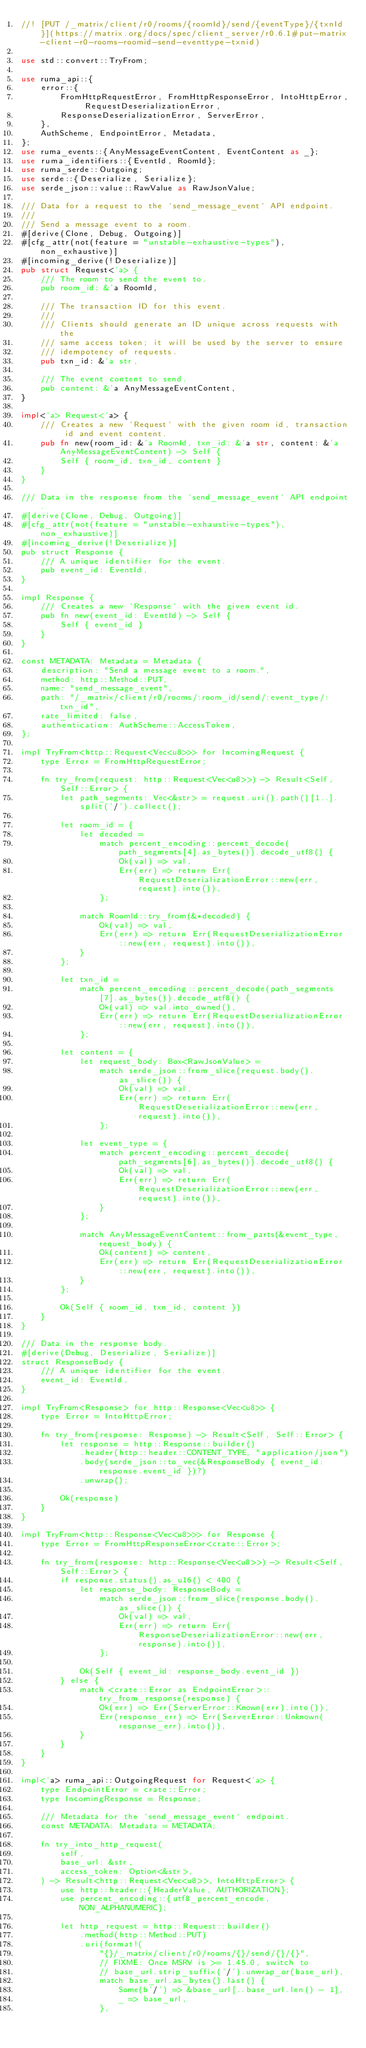<code> <loc_0><loc_0><loc_500><loc_500><_Rust_>//! [PUT /_matrix/client/r0/rooms/{roomId}/send/{eventType}/{txnId}](https://matrix.org/docs/spec/client_server/r0.6.1#put-matrix-client-r0-rooms-roomid-send-eventtype-txnid)

use std::convert::TryFrom;

use ruma_api::{
    error::{
        FromHttpRequestError, FromHttpResponseError, IntoHttpError, RequestDeserializationError,
        ResponseDeserializationError, ServerError,
    },
    AuthScheme, EndpointError, Metadata,
};
use ruma_events::{AnyMessageEventContent, EventContent as _};
use ruma_identifiers::{EventId, RoomId};
use ruma_serde::Outgoing;
use serde::{Deserialize, Serialize};
use serde_json::value::RawValue as RawJsonValue;

/// Data for a request to the `send_message_event` API endpoint.
///
/// Send a message event to a room.
#[derive(Clone, Debug, Outgoing)]
#[cfg_attr(not(feature = "unstable-exhaustive-types"), non_exhaustive)]
#[incoming_derive(!Deserialize)]
pub struct Request<'a> {
    /// The room to send the event to.
    pub room_id: &'a RoomId,

    /// The transaction ID for this event.
    ///
    /// Clients should generate an ID unique across requests with the
    /// same access token; it will be used by the server to ensure
    /// idempotency of requests.
    pub txn_id: &'a str,

    /// The event content to send.
    pub content: &'a AnyMessageEventContent,
}

impl<'a> Request<'a> {
    /// Creates a new `Request` with the given room id, transaction id and event content.
    pub fn new(room_id: &'a RoomId, txn_id: &'a str, content: &'a AnyMessageEventContent) -> Self {
        Self { room_id, txn_id, content }
    }
}

/// Data in the response from the `send_message_event` API endpoint.
#[derive(Clone, Debug, Outgoing)]
#[cfg_attr(not(feature = "unstable-exhaustive-types"), non_exhaustive)]
#[incoming_derive(!Deserialize)]
pub struct Response {
    /// A unique identifier for the event.
    pub event_id: EventId,
}

impl Response {
    /// Creates a new `Response` with the given event id.
    pub fn new(event_id: EventId) -> Self {
        Self { event_id }
    }
}

const METADATA: Metadata = Metadata {
    description: "Send a message event to a room.",
    method: http::Method::PUT,
    name: "send_message_event",
    path: "/_matrix/client/r0/rooms/:room_id/send/:event_type/:txn_id",
    rate_limited: false,
    authentication: AuthScheme::AccessToken,
};

impl TryFrom<http::Request<Vec<u8>>> for IncomingRequest {
    type Error = FromHttpRequestError;

    fn try_from(request: http::Request<Vec<u8>>) -> Result<Self, Self::Error> {
        let path_segments: Vec<&str> = request.uri().path()[1..].split('/').collect();

        let room_id = {
            let decoded =
                match percent_encoding::percent_decode(path_segments[4].as_bytes()).decode_utf8() {
                    Ok(val) => val,
                    Err(err) => return Err(RequestDeserializationError::new(err, request).into()),
                };

            match RoomId::try_from(&*decoded) {
                Ok(val) => val,
                Err(err) => return Err(RequestDeserializationError::new(err, request).into()),
            }
        };

        let txn_id =
            match percent_encoding::percent_decode(path_segments[7].as_bytes()).decode_utf8() {
                Ok(val) => val.into_owned(),
                Err(err) => return Err(RequestDeserializationError::new(err, request).into()),
            };

        let content = {
            let request_body: Box<RawJsonValue> =
                match serde_json::from_slice(request.body().as_slice()) {
                    Ok(val) => val,
                    Err(err) => return Err(RequestDeserializationError::new(err, request).into()),
                };

            let event_type = {
                match percent_encoding::percent_decode(path_segments[6].as_bytes()).decode_utf8() {
                    Ok(val) => val,
                    Err(err) => return Err(RequestDeserializationError::new(err, request).into()),
                }
            };

            match AnyMessageEventContent::from_parts(&event_type, request_body) {
                Ok(content) => content,
                Err(err) => return Err(RequestDeserializationError::new(err, request).into()),
            }
        };

        Ok(Self { room_id, txn_id, content })
    }
}

/// Data in the response body.
#[derive(Debug, Deserialize, Serialize)]
struct ResponseBody {
    /// A unique identifier for the event.
    event_id: EventId,
}

impl TryFrom<Response> for http::Response<Vec<u8>> {
    type Error = IntoHttpError;

    fn try_from(response: Response) -> Result<Self, Self::Error> {
        let response = http::Response::builder()
            .header(http::header::CONTENT_TYPE, "application/json")
            .body(serde_json::to_vec(&ResponseBody { event_id: response.event_id })?)
            .unwrap();

        Ok(response)
    }
}

impl TryFrom<http::Response<Vec<u8>>> for Response {
    type Error = FromHttpResponseError<crate::Error>;

    fn try_from(response: http::Response<Vec<u8>>) -> Result<Self, Self::Error> {
        if response.status().as_u16() < 400 {
            let response_body: ResponseBody =
                match serde_json::from_slice(response.body().as_slice()) {
                    Ok(val) => val,
                    Err(err) => return Err(ResponseDeserializationError::new(err, response).into()),
                };

            Ok(Self { event_id: response_body.event_id })
        } else {
            match <crate::Error as EndpointError>::try_from_response(response) {
                Ok(err) => Err(ServerError::Known(err).into()),
                Err(response_err) => Err(ServerError::Unknown(response_err).into()),
            }
        }
    }
}

impl<'a> ruma_api::OutgoingRequest for Request<'a> {
    type EndpointError = crate::Error;
    type IncomingResponse = Response;

    /// Metadata for the `send_message_event` endpoint.
    const METADATA: Metadata = METADATA;

    fn try_into_http_request(
        self,
        base_url: &str,
        access_token: Option<&str>,
    ) -> Result<http::Request<Vec<u8>>, IntoHttpError> {
        use http::header::{HeaderValue, AUTHORIZATION};
        use percent_encoding::{utf8_percent_encode, NON_ALPHANUMERIC};

        let http_request = http::Request::builder()
            .method(http::Method::PUT)
            .uri(format!(
                "{}/_matrix/client/r0/rooms/{}/send/{}/{}",
                // FIXME: Once MSRV is >= 1.45.0, switch to
                // base_url.strip_suffix('/').unwrap_or(base_url),
                match base_url.as_bytes().last() {
                    Some(b'/') => &base_url[..base_url.len() - 1],
                    _ => base_url,
                },</code> 